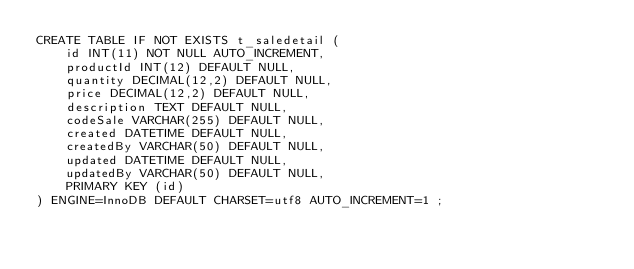Convert code to text. <code><loc_0><loc_0><loc_500><loc_500><_SQL_>CREATE TABLE IF NOT EXISTS t_saledetail (
	id INT(11) NOT NULL AUTO_INCREMENT,
	productId INT(12) DEFAULT NULL,
	quantity DECIMAL(12,2) DEFAULT NULL,
	price DECIMAL(12,2) DEFAULT NULL,
	description TEXT DEFAULT NULL,
	codeSale VARCHAR(255) DEFAULT NULL,
	created DATETIME DEFAULT NULL,
	createdBy VARCHAR(50) DEFAULT NULL,
	updated DATETIME DEFAULT NULL,
	updatedBy VARCHAR(50) DEFAULT NULL,
	PRIMARY KEY (id)
) ENGINE=InnoDB DEFAULT CHARSET=utf8 AUTO_INCREMENT=1 ;</code> 